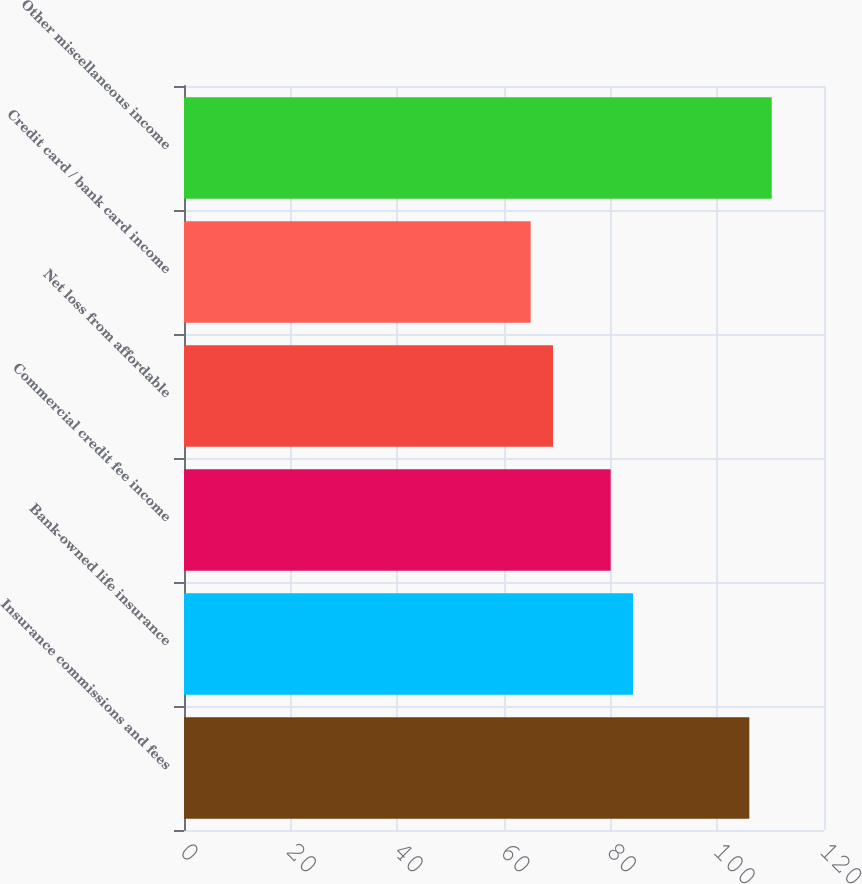Convert chart to OTSL. <chart><loc_0><loc_0><loc_500><loc_500><bar_chart><fcel>Insurance commissions and fees<fcel>Bank-owned life insurance<fcel>Commercial credit fee income<fcel>Net loss from affordable<fcel>Credit card / bank card income<fcel>Other miscellaneous income<nl><fcel>106<fcel>84.2<fcel>80<fcel>69.2<fcel>65<fcel>110.2<nl></chart> 